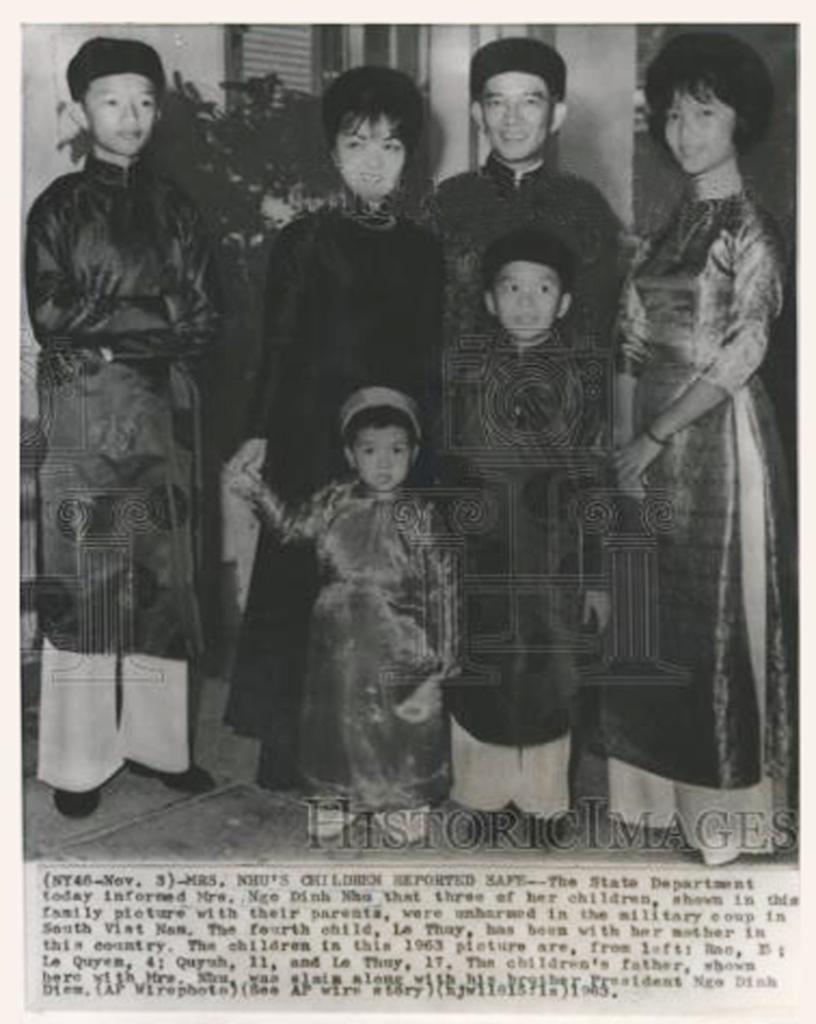In one or two sentences, can you explain what this image depicts? This is a black and white image, we can see there is a group of persons standing in the middle of this image, and there is some text written at the bottom of this image. 